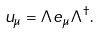Convert formula to latex. <formula><loc_0><loc_0><loc_500><loc_500>u _ { \mu } = \Lambda e _ { \mu } \Lambda ^ { \dag } .</formula> 